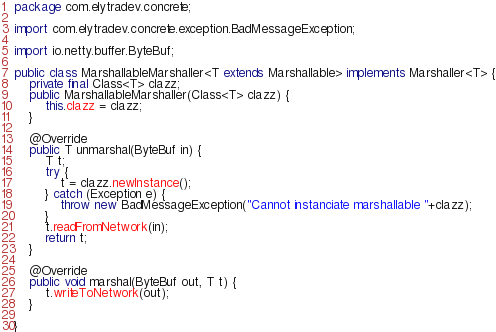Convert code to text. <code><loc_0><loc_0><loc_500><loc_500><_Java_>package com.elytradev.concrete;

import com.elytradev.concrete.exception.BadMessageException;

import io.netty.buffer.ByteBuf;

public class MarshallableMarshaller<T extends Marshallable> implements Marshaller<T> {
	private final Class<T> clazz;
	public MarshallableMarshaller(Class<T> clazz) {
		this.clazz = clazz;
	}
	
	@Override
	public T unmarshal(ByteBuf in) {
		T t;
		try {
			t = clazz.newInstance();
		} catch (Exception e) {
			throw new BadMessageException("Cannot instanciate marshallable "+clazz);
		}
		t.readFromNetwork(in);
		return t;
	}

	@Override
	public void marshal(ByteBuf out, T t) {
		t.writeToNetwork(out);
	}

}
</code> 